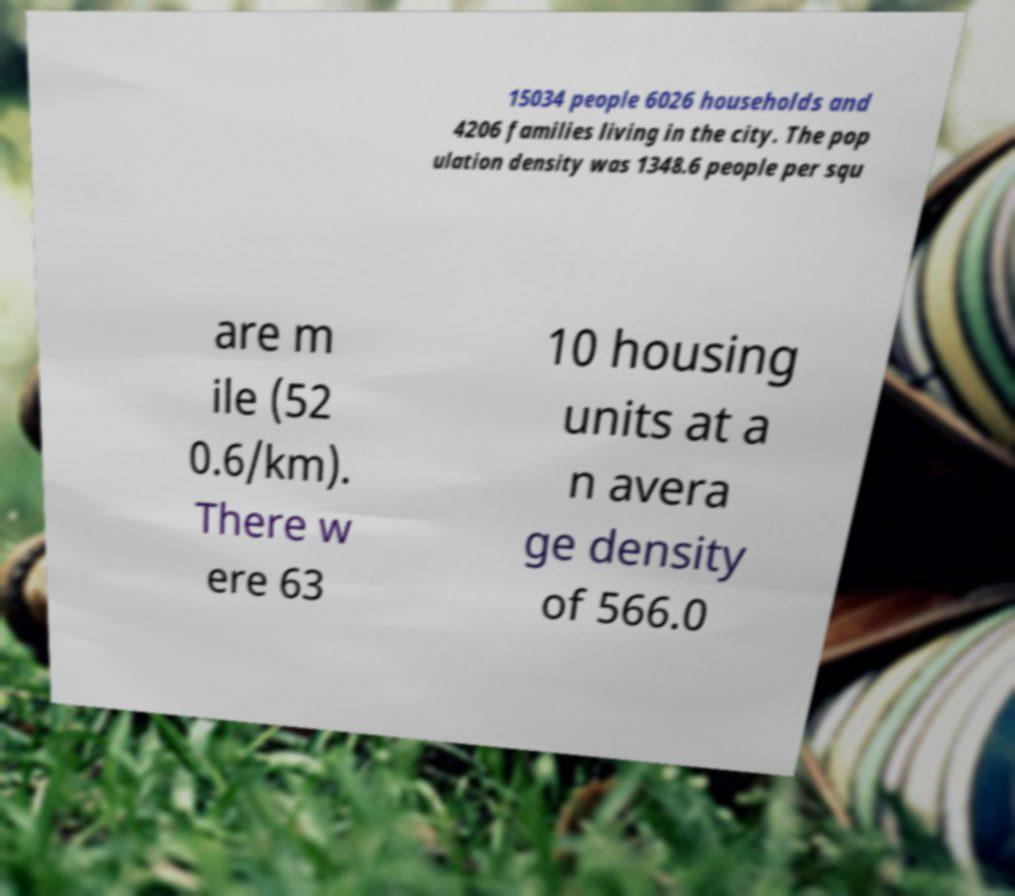Please read and relay the text visible in this image. What does it say? 15034 people 6026 households and 4206 families living in the city. The pop ulation density was 1348.6 people per squ are m ile (52 0.6/km). There w ere 63 10 housing units at a n avera ge density of 566.0 